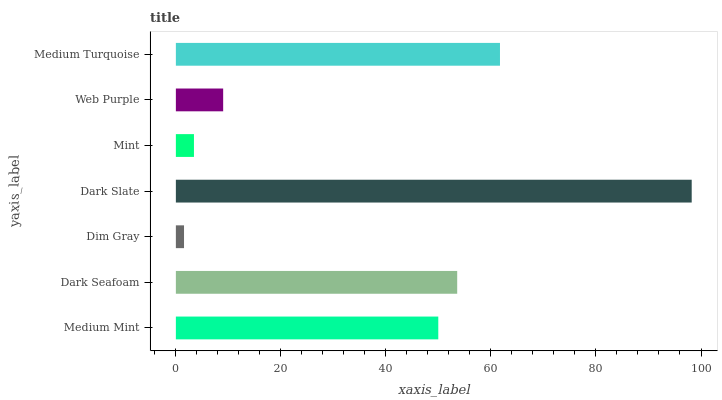Is Dim Gray the minimum?
Answer yes or no. Yes. Is Dark Slate the maximum?
Answer yes or no. Yes. Is Dark Seafoam the minimum?
Answer yes or no. No. Is Dark Seafoam the maximum?
Answer yes or no. No. Is Dark Seafoam greater than Medium Mint?
Answer yes or no. Yes. Is Medium Mint less than Dark Seafoam?
Answer yes or no. Yes. Is Medium Mint greater than Dark Seafoam?
Answer yes or no. No. Is Dark Seafoam less than Medium Mint?
Answer yes or no. No. Is Medium Mint the high median?
Answer yes or no. Yes. Is Medium Mint the low median?
Answer yes or no. Yes. Is Dark Seafoam the high median?
Answer yes or no. No. Is Dark Seafoam the low median?
Answer yes or no. No. 